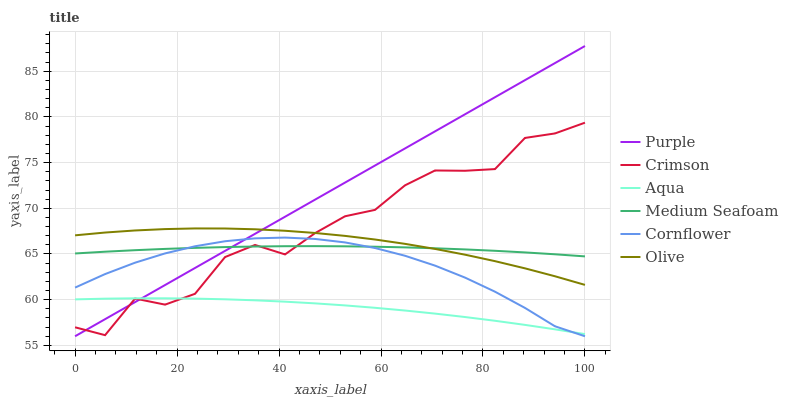Does Aqua have the minimum area under the curve?
Answer yes or no. Yes. Does Purple have the maximum area under the curve?
Answer yes or no. Yes. Does Purple have the minimum area under the curve?
Answer yes or no. No. Does Aqua have the maximum area under the curve?
Answer yes or no. No. Is Purple the smoothest?
Answer yes or no. Yes. Is Crimson the roughest?
Answer yes or no. Yes. Is Aqua the smoothest?
Answer yes or no. No. Is Aqua the roughest?
Answer yes or no. No. Does Cornflower have the lowest value?
Answer yes or no. Yes. Does Aqua have the lowest value?
Answer yes or no. No. Does Purple have the highest value?
Answer yes or no. Yes. Does Aqua have the highest value?
Answer yes or no. No. Is Cornflower less than Olive?
Answer yes or no. Yes. Is Olive greater than Aqua?
Answer yes or no. Yes. Does Olive intersect Medium Seafoam?
Answer yes or no. Yes. Is Olive less than Medium Seafoam?
Answer yes or no. No. Is Olive greater than Medium Seafoam?
Answer yes or no. No. Does Cornflower intersect Olive?
Answer yes or no. No. 